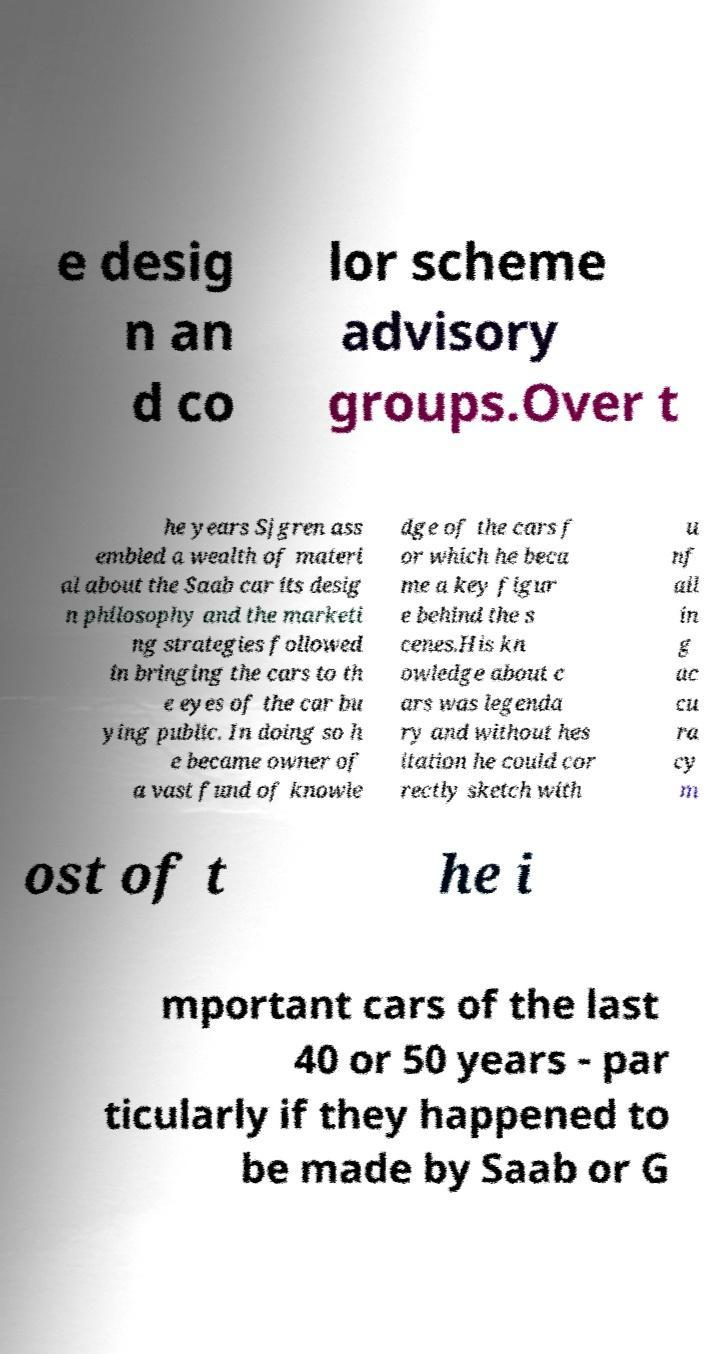Can you accurately transcribe the text from the provided image for me? e desig n an d co lor scheme advisory groups.Over t he years Sjgren ass embled a wealth of materi al about the Saab car its desig n philosophy and the marketi ng strategies followed in bringing the cars to th e eyes of the car bu ying public. In doing so h e became owner of a vast fund of knowle dge of the cars f or which he beca me a key figur e behind the s cenes.His kn owledge about c ars was legenda ry and without hes itation he could cor rectly sketch with u nf ail in g ac cu ra cy m ost of t he i mportant cars of the last 40 or 50 years - par ticularly if they happened to be made by Saab or G 